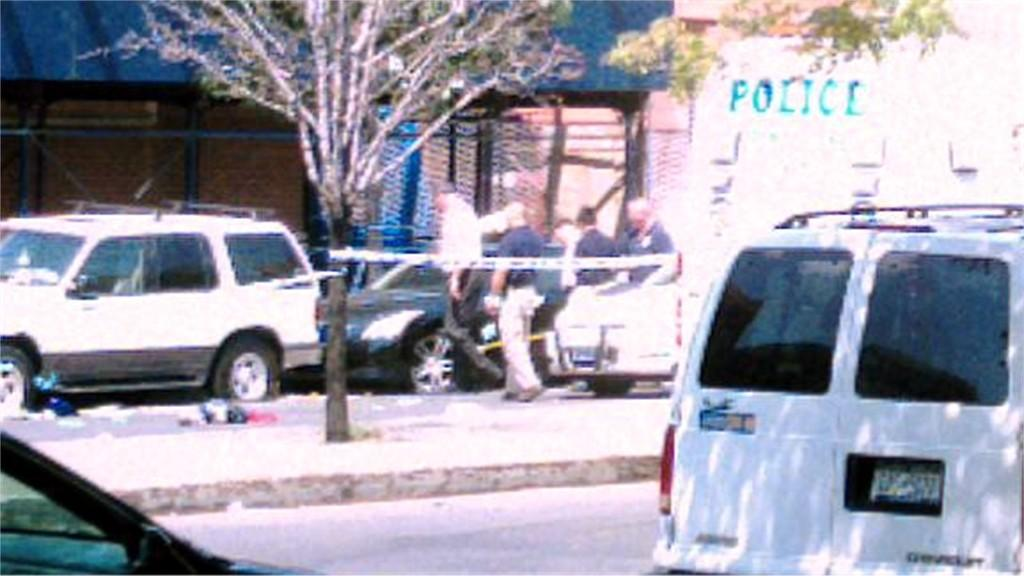<image>
Relay a brief, clear account of the picture shown. A white can sits near a Police van on the street 